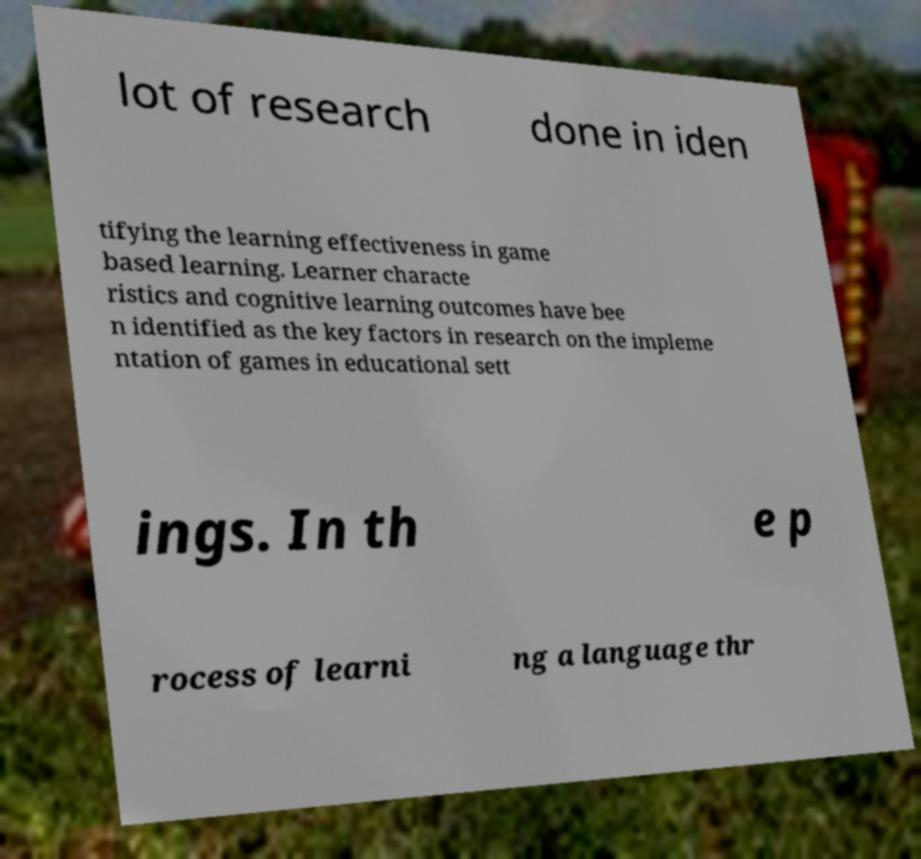Can you read and provide the text displayed in the image?This photo seems to have some interesting text. Can you extract and type it out for me? lot of research done in iden tifying the learning effectiveness in game based learning. Learner characte ristics and cognitive learning outcomes have bee n identified as the key factors in research on the impleme ntation of games in educational sett ings. In th e p rocess of learni ng a language thr 